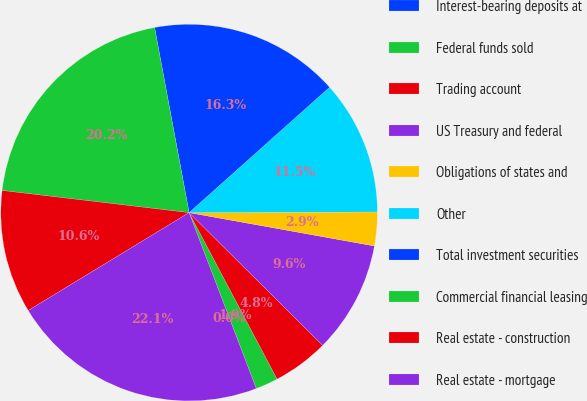Convert chart. <chart><loc_0><loc_0><loc_500><loc_500><pie_chart><fcel>Interest-bearing deposits at<fcel>Federal funds sold<fcel>Trading account<fcel>US Treasury and federal<fcel>Obligations of states and<fcel>Other<fcel>Total investment securities<fcel>Commercial financial leasing<fcel>Real estate - construction<fcel>Real estate - mortgage<nl><fcel>0.0%<fcel>1.93%<fcel>4.81%<fcel>9.62%<fcel>2.89%<fcel>11.54%<fcel>16.34%<fcel>20.19%<fcel>10.58%<fcel>22.11%<nl></chart> 